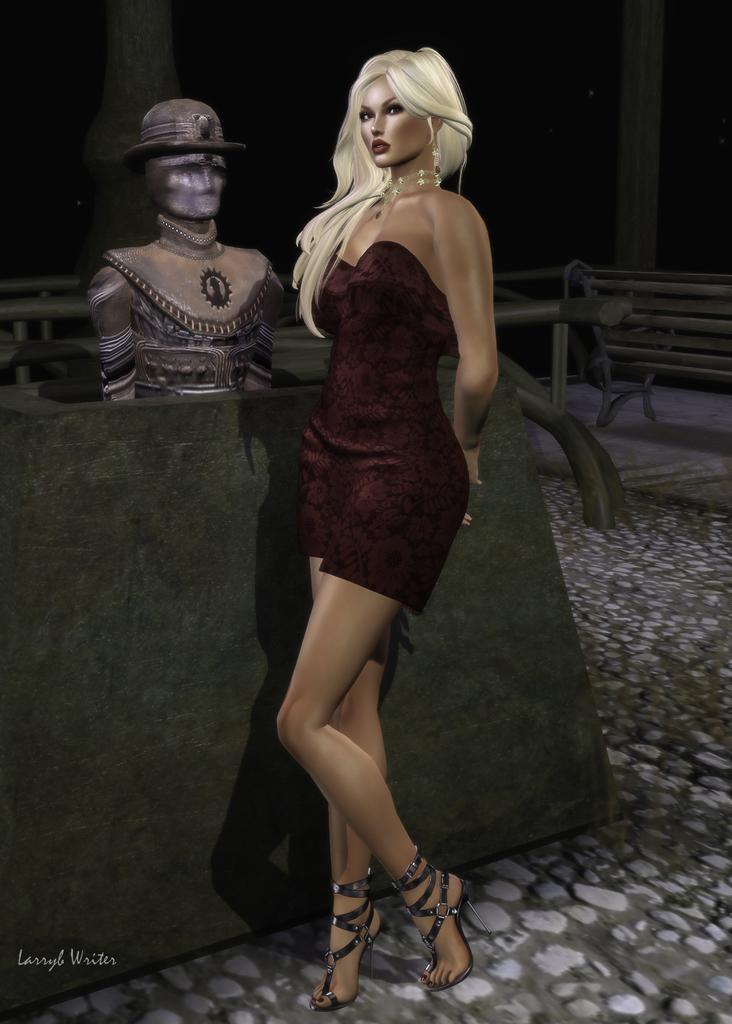Could you give a brief overview of what you see in this image? This is an animated image. In the center there is a woman wearing a dress and standing on the ground and we can see a sculpture of a person. In the background there is a bench and some other items placed on the ground. At the bottom left corner there is a text on the image. 